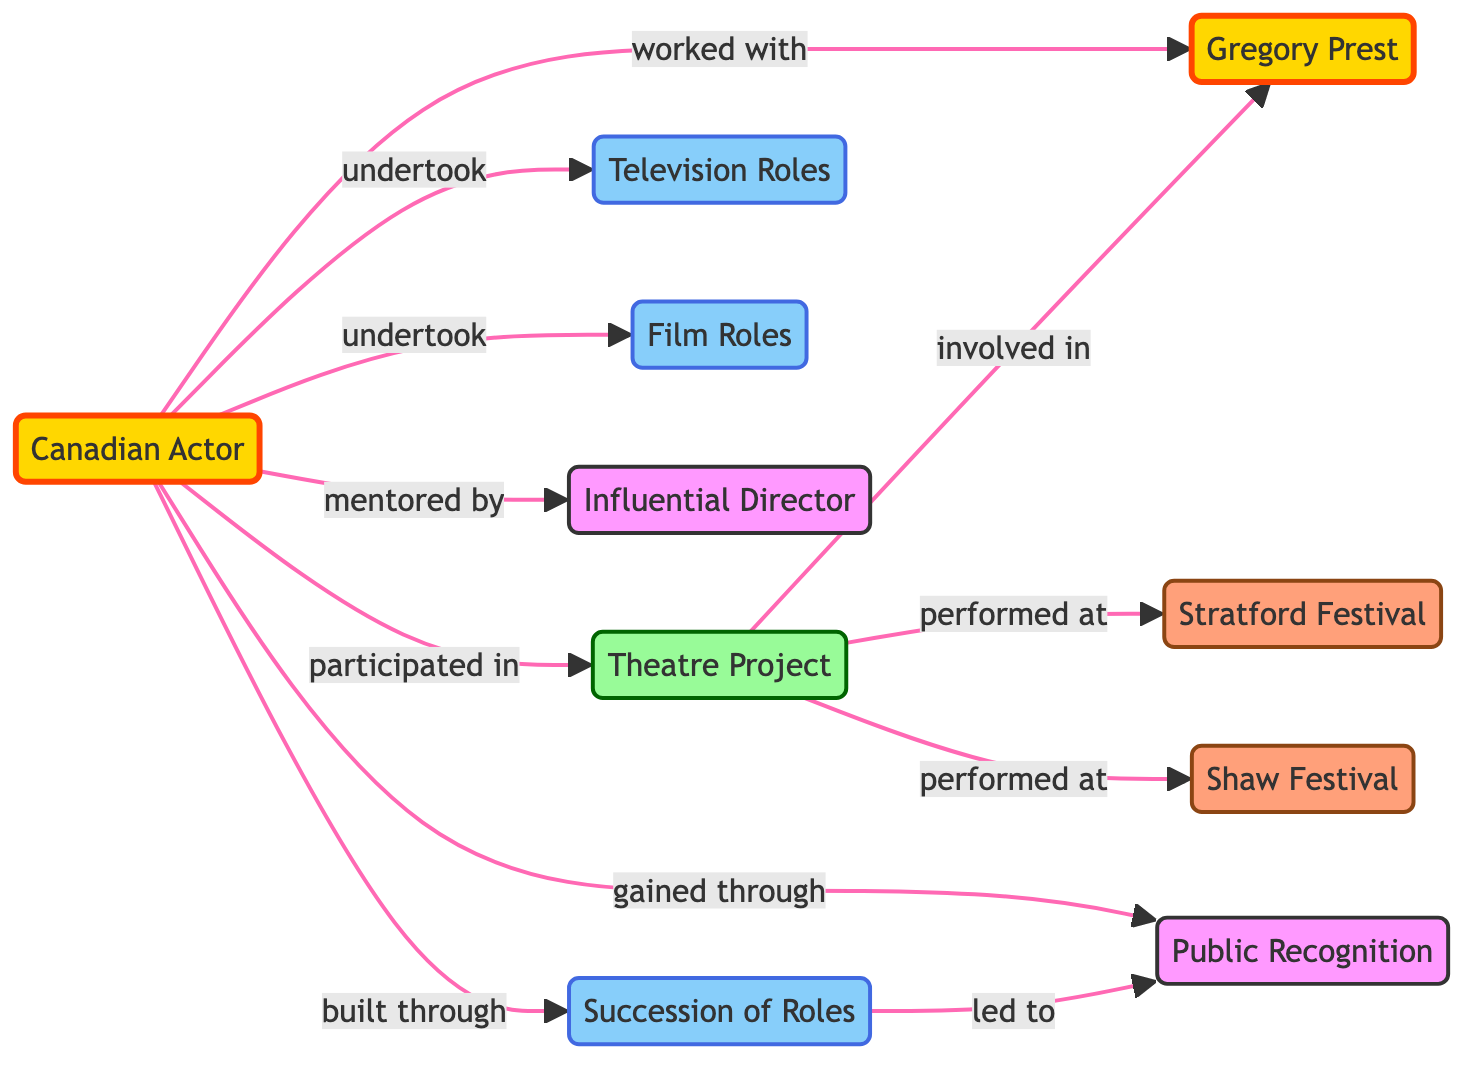What is the total number of nodes in the diagram? The diagram lists the following nodes: Canadian Actor, Gregory Prest, Theatre Project, Stratford Festival, Shaw Festival, Television Roles, Film Roles, Influential Director, Succession of Roles, and Public Recognition. Counting these, there are 10 nodes total.
Answer: 10 What role is connected to the Canadian Actor through the relationship "undertook"? The nodes that the Canadian Actor is connected to with the relationship "undertook" are Television Roles and Film Roles. Since the question asks for one, either one is acceptable, but I will choose Television Roles as a specific answer.
Answer: Television Roles How many festivals are mentioned in the diagram? The festivals represented in the diagram are Stratford Festival and Shaw Festival. There are only two distinct festivals present.
Answer: 2 Which node received mentorship from the Influential Director? The relationship indicates that the Canadian Actor is mentored by the Influential Director. Therefore, the answer is the Canadian Actor.
Answer: Canadian Actor What two types of roles did the Canadian Actor undertake? The roles that the Canadian Actor undertook include Television Roles and Film Roles, both specified in the diagram under their respective connections.
Answer: Television Roles and Film Roles How does the Succession of Roles relate to Public Recognition? The edge from Succession of Roles to Public Recognition is labeled "led to". This indicates that the succession of roles the Canadian Actor had is a contributing factor towards gaining public recognition.
Answer: led to What project is Gregory Prest involved in according to the diagram? The diagram shows that Gregory Prest is involved in the Theatre Project, which connects him to both the Canadian Actor and the project itself.
Answer: Theatre Project Which festival is linked with the Theatre Project? The Theatre Project is linked to both the Stratford Festival and the Shaw Festival, with edges representing the relationship "performed at". Either festival can be identified, I will choose Stratford Festival as a specific response.
Answer: Stratford Festival How many edges are associated with the Canadian Actor in the diagram? The Canadian Actor has a total of six edges connecting to Gregory Prest, Theatre Project, Television Roles, Film Roles, Influential Director, and Succession of Roles. Counting these lines gives a total of six edges.
Answer: 6 